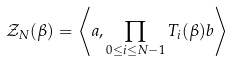<formula> <loc_0><loc_0><loc_500><loc_500>\mathcal { Z } _ { N } ( \beta ) = \left \langle a , \prod _ { 0 \leq i \leq N - 1 } T _ { i } ( \beta ) b \right \rangle</formula> 